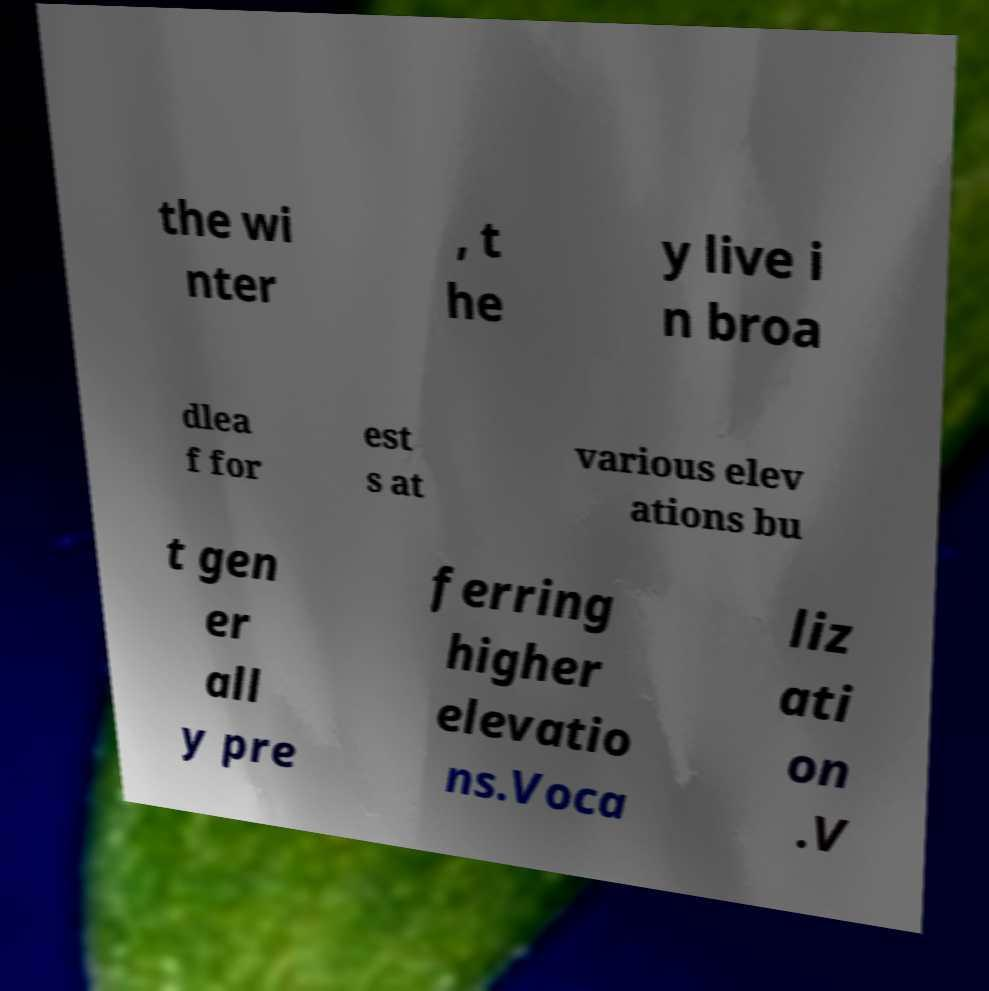For documentation purposes, I need the text within this image transcribed. Could you provide that? the wi nter , t he y live i n broa dlea f for est s at various elev ations bu t gen er all y pre ferring higher elevatio ns.Voca liz ati on .V 